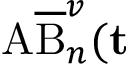Convert formula to latex. <formula><loc_0><loc_0><loc_500><loc_500>A \overline { B } _ { n } ^ { v } ( \mathbf t</formula> 